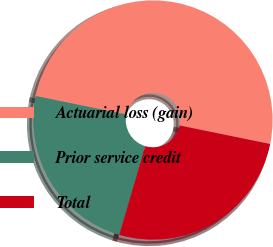Convert chart to OTSL. <chart><loc_0><loc_0><loc_500><loc_500><pie_chart><fcel>Actuarial loss (gain)<fcel>Prior service credit<fcel>Total<nl><fcel>50.0%<fcel>23.68%<fcel>26.32%<nl></chart> 